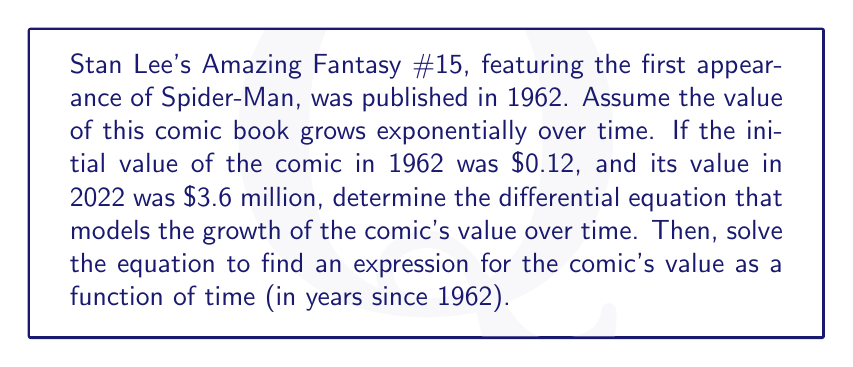Provide a solution to this math problem. Let's approach this step-by-step:

1) Let $V(t)$ be the value of the comic book in dollars at time $t$, where $t$ is measured in years since 1962.

2) We're told that the growth is exponential, which means the rate of change of the value is proportional to the current value. This can be expressed as:

   $$\frac{dV}{dt} = kV$$

   where $k$ is the growth rate constant.

3) We know two points:
   - At $t=0$ (1962), $V(0) = 0.12$
   - At $t=60$ (2022), $V(60) = 3,600,000$

4) The general solution to this differential equation is:

   $$V(t) = Ce^{kt}$$

   where $C$ is a constant we need to determine.

5) Using the initial condition:

   $0.12 = Ce^{k(0)}$
   $C = 0.12$

6) Now our equation is:

   $$V(t) = 0.12e^{kt}$$

7) Using the second condition:

   $3,600,000 = 0.12e^{k(60)}$

8) Solving for $k$:

   $$\frac{3,600,000}{0.12} = e^{60k}$$
   $$30,000,000 = e^{60k}$$
   $$\ln(30,000,000) = 60k$$
   $$k = \frac{\ln(30,000,000)}{60} \approx 0.2877$$

9) Therefore, the differential equation is:

   $$\frac{dV}{dt} = 0.2877V$$

10) And the solution, expressing the value as a function of time, is:

    $$V(t) = 0.12e^{0.2877t}$$
Answer: The differential equation is $\frac{dV}{dt} = 0.2877V$, and the solution is $V(t) = 0.12e^{0.2877t}$, where $V$ is in dollars and $t$ is years since 1962. 